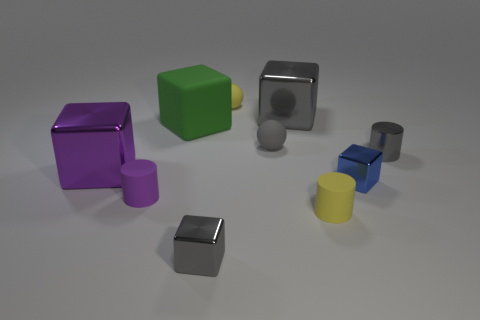There is a yellow sphere that is the same size as the gray sphere; what material is it?
Ensure brevity in your answer.  Rubber. Do the tiny purple cylinder on the left side of the small metal cylinder and the gray thing right of the large gray thing have the same material?
Provide a short and direct response. No. There is a large thing that is to the right of the big matte cube; is its shape the same as the tiny metal object in front of the tiny blue shiny cube?
Your answer should be compact. Yes. How big is the gray metal thing that is behind the yellow rubber cylinder and left of the yellow cylinder?
Keep it short and to the point. Large. How many other objects are the same color as the large matte block?
Provide a succinct answer. 0. Are the small yellow object in front of the tiny gray shiny cylinder and the green object made of the same material?
Give a very brief answer. Yes. Are there any other things that are the same size as the gray metal cylinder?
Provide a short and direct response. Yes. Is the number of gray spheres that are to the right of the yellow cylinder less than the number of tiny things that are behind the green block?
Offer a terse response. Yes. Is there any other thing that has the same shape as the gray rubber thing?
Your response must be concise. Yes. What material is the big thing that is the same color as the metal cylinder?
Offer a terse response. Metal. 